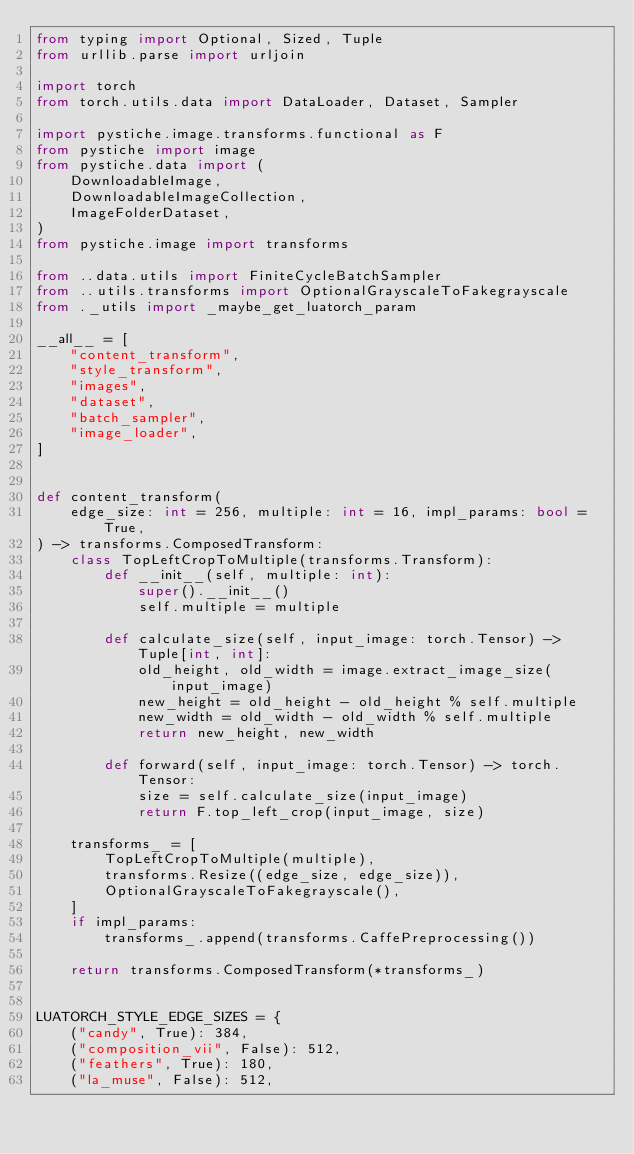<code> <loc_0><loc_0><loc_500><loc_500><_Python_>from typing import Optional, Sized, Tuple
from urllib.parse import urljoin

import torch
from torch.utils.data import DataLoader, Dataset, Sampler

import pystiche.image.transforms.functional as F
from pystiche import image
from pystiche.data import (
    DownloadableImage,
    DownloadableImageCollection,
    ImageFolderDataset,
)
from pystiche.image import transforms

from ..data.utils import FiniteCycleBatchSampler
from ..utils.transforms import OptionalGrayscaleToFakegrayscale
from ._utils import _maybe_get_luatorch_param

__all__ = [
    "content_transform",
    "style_transform",
    "images",
    "dataset",
    "batch_sampler",
    "image_loader",
]


def content_transform(
    edge_size: int = 256, multiple: int = 16, impl_params: bool = True,
) -> transforms.ComposedTransform:
    class TopLeftCropToMultiple(transforms.Transform):
        def __init__(self, multiple: int):
            super().__init__()
            self.multiple = multiple

        def calculate_size(self, input_image: torch.Tensor) -> Tuple[int, int]:
            old_height, old_width = image.extract_image_size(input_image)
            new_height = old_height - old_height % self.multiple
            new_width = old_width - old_width % self.multiple
            return new_height, new_width

        def forward(self, input_image: torch.Tensor) -> torch.Tensor:
            size = self.calculate_size(input_image)
            return F.top_left_crop(input_image, size)

    transforms_ = [
        TopLeftCropToMultiple(multiple),
        transforms.Resize((edge_size, edge_size)),
        OptionalGrayscaleToFakegrayscale(),
    ]
    if impl_params:
        transforms_.append(transforms.CaffePreprocessing())

    return transforms.ComposedTransform(*transforms_)


LUATORCH_STYLE_EDGE_SIZES = {
    ("candy", True): 384,
    ("composition_vii", False): 512,
    ("feathers", True): 180,
    ("la_muse", False): 512,</code> 